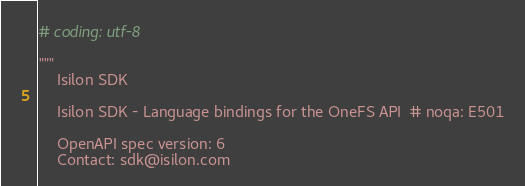<code> <loc_0><loc_0><loc_500><loc_500><_Python_># coding: utf-8

"""
    Isilon SDK

    Isilon SDK - Language bindings for the OneFS API  # noqa: E501

    OpenAPI spec version: 6
    Contact: sdk@isilon.com</code> 